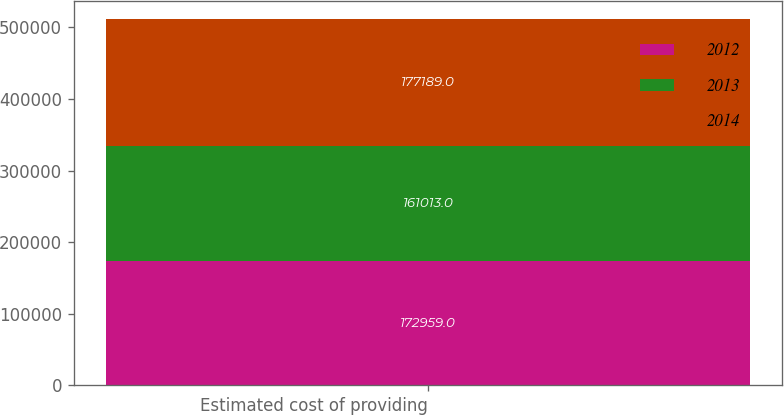Convert chart to OTSL. <chart><loc_0><loc_0><loc_500><loc_500><stacked_bar_chart><ecel><fcel>Estimated cost of providing<nl><fcel>2012<fcel>172959<nl><fcel>2013<fcel>161013<nl><fcel>2014<fcel>177189<nl></chart> 